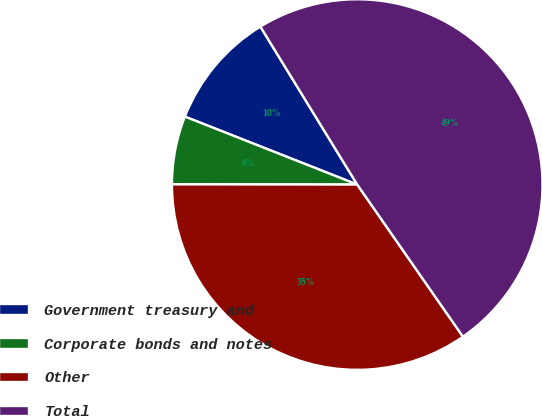Convert chart. <chart><loc_0><loc_0><loc_500><loc_500><pie_chart><fcel>Government treasury and<fcel>Corporate bonds and notes<fcel>Other<fcel>Total<nl><fcel>10.27%<fcel>5.96%<fcel>34.69%<fcel>49.09%<nl></chart> 